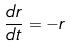Convert formula to latex. <formula><loc_0><loc_0><loc_500><loc_500>\frac { d r } { d t } = - r</formula> 